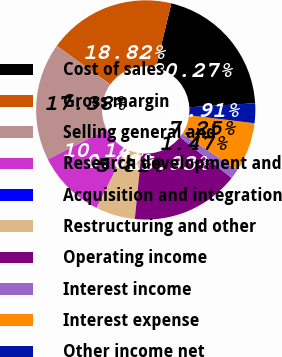Convert chart to OTSL. <chart><loc_0><loc_0><loc_500><loc_500><pie_chart><fcel>Cost of sales<fcel>Gross margin<fcel>Selling general and<fcel>Research development and<fcel>Acquisition and integration<fcel>Restructuring and other<fcel>Operating income<fcel>Interest income<fcel>Interest expense<fcel>Other income net<nl><fcel>20.27%<fcel>18.82%<fcel>17.38%<fcel>10.14%<fcel>0.02%<fcel>5.81%<fcel>15.93%<fcel>1.47%<fcel>7.25%<fcel>2.91%<nl></chart> 